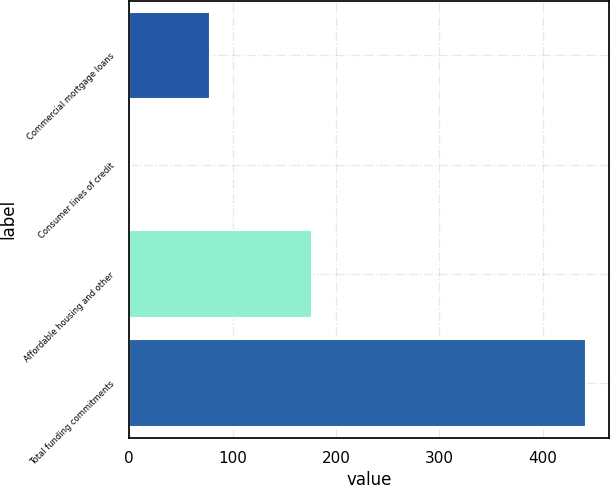<chart> <loc_0><loc_0><loc_500><loc_500><bar_chart><fcel>Commercial mortgage loans<fcel>Consumer lines of credit<fcel>Affordable housing and other<fcel>Total funding commitments<nl><fcel>78<fcel>2<fcel>177<fcel>442<nl></chart> 